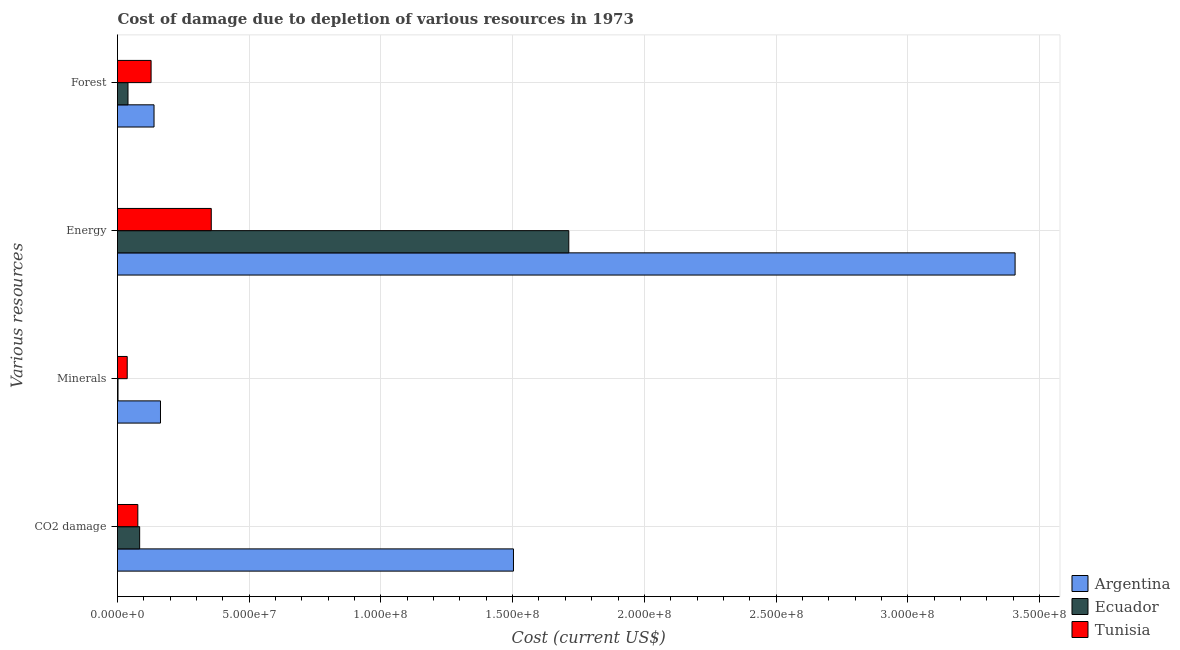How many different coloured bars are there?
Your response must be concise. 3. How many groups of bars are there?
Provide a short and direct response. 4. Are the number of bars per tick equal to the number of legend labels?
Your response must be concise. Yes. Are the number of bars on each tick of the Y-axis equal?
Make the answer very short. Yes. How many bars are there on the 3rd tick from the top?
Make the answer very short. 3. How many bars are there on the 3rd tick from the bottom?
Provide a succinct answer. 3. What is the label of the 4th group of bars from the top?
Your response must be concise. CO2 damage. What is the cost of damage due to depletion of energy in Tunisia?
Provide a succinct answer. 3.56e+07. Across all countries, what is the maximum cost of damage due to depletion of forests?
Make the answer very short. 1.39e+07. Across all countries, what is the minimum cost of damage due to depletion of minerals?
Keep it short and to the point. 1.93e+05. In which country was the cost of damage due to depletion of coal minimum?
Keep it short and to the point. Tunisia. What is the total cost of damage due to depletion of coal in the graph?
Offer a very short reply. 1.66e+08. What is the difference between the cost of damage due to depletion of energy in Tunisia and that in Argentina?
Your answer should be very brief. -3.05e+08. What is the difference between the cost of damage due to depletion of coal in Tunisia and the cost of damage due to depletion of energy in Ecuador?
Provide a short and direct response. -1.64e+08. What is the average cost of damage due to depletion of coal per country?
Give a very brief answer. 5.55e+07. What is the difference between the cost of damage due to depletion of coal and cost of damage due to depletion of energy in Argentina?
Keep it short and to the point. -1.90e+08. In how many countries, is the cost of damage due to depletion of coal greater than 130000000 US$?
Offer a very short reply. 1. What is the ratio of the cost of damage due to depletion of minerals in Ecuador to that in Argentina?
Give a very brief answer. 0.01. What is the difference between the highest and the second highest cost of damage due to depletion of minerals?
Make the answer very short. 1.26e+07. What is the difference between the highest and the lowest cost of damage due to depletion of coal?
Give a very brief answer. 1.43e+08. Is the sum of the cost of damage due to depletion of forests in Argentina and Tunisia greater than the maximum cost of damage due to depletion of coal across all countries?
Your response must be concise. No. What does the 3rd bar from the bottom in Forest represents?
Your answer should be compact. Tunisia. What is the difference between two consecutive major ticks on the X-axis?
Offer a very short reply. 5.00e+07. Are the values on the major ticks of X-axis written in scientific E-notation?
Your response must be concise. Yes. Does the graph contain any zero values?
Your answer should be very brief. No. Where does the legend appear in the graph?
Keep it short and to the point. Bottom right. What is the title of the graph?
Make the answer very short. Cost of damage due to depletion of various resources in 1973 . What is the label or title of the X-axis?
Ensure brevity in your answer.  Cost (current US$). What is the label or title of the Y-axis?
Give a very brief answer. Various resources. What is the Cost (current US$) in Argentina in CO2 damage?
Make the answer very short. 1.50e+08. What is the Cost (current US$) of Ecuador in CO2 damage?
Keep it short and to the point. 8.41e+06. What is the Cost (current US$) in Tunisia in CO2 damage?
Offer a terse response. 7.72e+06. What is the Cost (current US$) of Argentina in Minerals?
Make the answer very short. 1.63e+07. What is the Cost (current US$) of Ecuador in Minerals?
Keep it short and to the point. 1.93e+05. What is the Cost (current US$) of Tunisia in Minerals?
Your answer should be very brief. 3.69e+06. What is the Cost (current US$) of Argentina in Energy?
Keep it short and to the point. 3.41e+08. What is the Cost (current US$) in Ecuador in Energy?
Ensure brevity in your answer.  1.71e+08. What is the Cost (current US$) in Tunisia in Energy?
Give a very brief answer. 3.56e+07. What is the Cost (current US$) in Argentina in Forest?
Provide a succinct answer. 1.39e+07. What is the Cost (current US$) of Ecuador in Forest?
Your response must be concise. 3.98e+06. What is the Cost (current US$) of Tunisia in Forest?
Your response must be concise. 1.28e+07. Across all Various resources, what is the maximum Cost (current US$) of Argentina?
Your answer should be very brief. 3.41e+08. Across all Various resources, what is the maximum Cost (current US$) in Ecuador?
Keep it short and to the point. 1.71e+08. Across all Various resources, what is the maximum Cost (current US$) of Tunisia?
Offer a very short reply. 3.56e+07. Across all Various resources, what is the minimum Cost (current US$) of Argentina?
Offer a very short reply. 1.39e+07. Across all Various resources, what is the minimum Cost (current US$) of Ecuador?
Make the answer very short. 1.93e+05. Across all Various resources, what is the minimum Cost (current US$) in Tunisia?
Your answer should be compact. 3.69e+06. What is the total Cost (current US$) of Argentina in the graph?
Give a very brief answer. 5.21e+08. What is the total Cost (current US$) of Ecuador in the graph?
Give a very brief answer. 1.84e+08. What is the total Cost (current US$) of Tunisia in the graph?
Offer a terse response. 5.97e+07. What is the difference between the Cost (current US$) of Argentina in CO2 damage and that in Minerals?
Give a very brief answer. 1.34e+08. What is the difference between the Cost (current US$) in Ecuador in CO2 damage and that in Minerals?
Make the answer very short. 8.22e+06. What is the difference between the Cost (current US$) of Tunisia in CO2 damage and that in Minerals?
Ensure brevity in your answer.  4.03e+06. What is the difference between the Cost (current US$) of Argentina in CO2 damage and that in Energy?
Your answer should be very brief. -1.90e+08. What is the difference between the Cost (current US$) of Ecuador in CO2 damage and that in Energy?
Your response must be concise. -1.63e+08. What is the difference between the Cost (current US$) of Tunisia in CO2 damage and that in Energy?
Your answer should be compact. -2.79e+07. What is the difference between the Cost (current US$) in Argentina in CO2 damage and that in Forest?
Offer a very short reply. 1.36e+08. What is the difference between the Cost (current US$) of Ecuador in CO2 damage and that in Forest?
Provide a succinct answer. 4.42e+06. What is the difference between the Cost (current US$) of Tunisia in CO2 damage and that in Forest?
Provide a succinct answer. -5.03e+06. What is the difference between the Cost (current US$) of Argentina in Minerals and that in Energy?
Provide a short and direct response. -3.24e+08. What is the difference between the Cost (current US$) in Ecuador in Minerals and that in Energy?
Ensure brevity in your answer.  -1.71e+08. What is the difference between the Cost (current US$) in Tunisia in Minerals and that in Energy?
Offer a very short reply. -3.19e+07. What is the difference between the Cost (current US$) of Argentina in Minerals and that in Forest?
Your answer should be very brief. 2.45e+06. What is the difference between the Cost (current US$) in Ecuador in Minerals and that in Forest?
Offer a terse response. -3.79e+06. What is the difference between the Cost (current US$) of Tunisia in Minerals and that in Forest?
Keep it short and to the point. -9.06e+06. What is the difference between the Cost (current US$) of Argentina in Energy and that in Forest?
Your response must be concise. 3.27e+08. What is the difference between the Cost (current US$) of Ecuador in Energy and that in Forest?
Provide a succinct answer. 1.67e+08. What is the difference between the Cost (current US$) of Tunisia in Energy and that in Forest?
Your response must be concise. 2.28e+07. What is the difference between the Cost (current US$) in Argentina in CO2 damage and the Cost (current US$) in Ecuador in Minerals?
Provide a short and direct response. 1.50e+08. What is the difference between the Cost (current US$) of Argentina in CO2 damage and the Cost (current US$) of Tunisia in Minerals?
Ensure brevity in your answer.  1.47e+08. What is the difference between the Cost (current US$) of Ecuador in CO2 damage and the Cost (current US$) of Tunisia in Minerals?
Keep it short and to the point. 4.72e+06. What is the difference between the Cost (current US$) in Argentina in CO2 damage and the Cost (current US$) in Ecuador in Energy?
Make the answer very short. -2.10e+07. What is the difference between the Cost (current US$) in Argentina in CO2 damage and the Cost (current US$) in Tunisia in Energy?
Offer a very short reply. 1.15e+08. What is the difference between the Cost (current US$) in Ecuador in CO2 damage and the Cost (current US$) in Tunisia in Energy?
Your answer should be very brief. -2.72e+07. What is the difference between the Cost (current US$) in Argentina in CO2 damage and the Cost (current US$) in Ecuador in Forest?
Your answer should be compact. 1.46e+08. What is the difference between the Cost (current US$) of Argentina in CO2 damage and the Cost (current US$) of Tunisia in Forest?
Offer a very short reply. 1.38e+08. What is the difference between the Cost (current US$) in Ecuador in CO2 damage and the Cost (current US$) in Tunisia in Forest?
Offer a terse response. -4.34e+06. What is the difference between the Cost (current US$) of Argentina in Minerals and the Cost (current US$) of Ecuador in Energy?
Keep it short and to the point. -1.55e+08. What is the difference between the Cost (current US$) in Argentina in Minerals and the Cost (current US$) in Tunisia in Energy?
Your response must be concise. -1.93e+07. What is the difference between the Cost (current US$) in Ecuador in Minerals and the Cost (current US$) in Tunisia in Energy?
Offer a very short reply. -3.54e+07. What is the difference between the Cost (current US$) of Argentina in Minerals and the Cost (current US$) of Ecuador in Forest?
Make the answer very short. 1.23e+07. What is the difference between the Cost (current US$) in Argentina in Minerals and the Cost (current US$) in Tunisia in Forest?
Ensure brevity in your answer.  3.56e+06. What is the difference between the Cost (current US$) in Ecuador in Minerals and the Cost (current US$) in Tunisia in Forest?
Ensure brevity in your answer.  -1.26e+07. What is the difference between the Cost (current US$) in Argentina in Energy and the Cost (current US$) in Ecuador in Forest?
Make the answer very short. 3.37e+08. What is the difference between the Cost (current US$) in Argentina in Energy and the Cost (current US$) in Tunisia in Forest?
Offer a very short reply. 3.28e+08. What is the difference between the Cost (current US$) in Ecuador in Energy and the Cost (current US$) in Tunisia in Forest?
Offer a very short reply. 1.59e+08. What is the average Cost (current US$) of Argentina per Various resources?
Provide a short and direct response. 1.30e+08. What is the average Cost (current US$) of Ecuador per Various resources?
Your answer should be very brief. 4.60e+07. What is the average Cost (current US$) of Tunisia per Various resources?
Keep it short and to the point. 1.49e+07. What is the difference between the Cost (current US$) in Argentina and Cost (current US$) in Ecuador in CO2 damage?
Your answer should be compact. 1.42e+08. What is the difference between the Cost (current US$) of Argentina and Cost (current US$) of Tunisia in CO2 damage?
Keep it short and to the point. 1.43e+08. What is the difference between the Cost (current US$) of Ecuador and Cost (current US$) of Tunisia in CO2 damage?
Keep it short and to the point. 6.91e+05. What is the difference between the Cost (current US$) of Argentina and Cost (current US$) of Ecuador in Minerals?
Keep it short and to the point. 1.61e+07. What is the difference between the Cost (current US$) of Argentina and Cost (current US$) of Tunisia in Minerals?
Give a very brief answer. 1.26e+07. What is the difference between the Cost (current US$) in Ecuador and Cost (current US$) in Tunisia in Minerals?
Ensure brevity in your answer.  -3.50e+06. What is the difference between the Cost (current US$) of Argentina and Cost (current US$) of Ecuador in Energy?
Keep it short and to the point. 1.69e+08. What is the difference between the Cost (current US$) in Argentina and Cost (current US$) in Tunisia in Energy?
Ensure brevity in your answer.  3.05e+08. What is the difference between the Cost (current US$) of Ecuador and Cost (current US$) of Tunisia in Energy?
Provide a short and direct response. 1.36e+08. What is the difference between the Cost (current US$) in Argentina and Cost (current US$) in Ecuador in Forest?
Ensure brevity in your answer.  9.88e+06. What is the difference between the Cost (current US$) of Argentina and Cost (current US$) of Tunisia in Forest?
Give a very brief answer. 1.12e+06. What is the difference between the Cost (current US$) of Ecuador and Cost (current US$) of Tunisia in Forest?
Make the answer very short. -8.77e+06. What is the ratio of the Cost (current US$) of Argentina in CO2 damage to that in Minerals?
Ensure brevity in your answer.  9.21. What is the ratio of the Cost (current US$) of Ecuador in CO2 damage to that in Minerals?
Provide a succinct answer. 43.66. What is the ratio of the Cost (current US$) of Tunisia in CO2 damage to that in Minerals?
Provide a succinct answer. 2.09. What is the ratio of the Cost (current US$) of Argentina in CO2 damage to that in Energy?
Offer a terse response. 0.44. What is the ratio of the Cost (current US$) of Ecuador in CO2 damage to that in Energy?
Provide a succinct answer. 0.05. What is the ratio of the Cost (current US$) of Tunisia in CO2 damage to that in Energy?
Give a very brief answer. 0.22. What is the ratio of the Cost (current US$) of Argentina in CO2 damage to that in Forest?
Your response must be concise. 10.84. What is the ratio of the Cost (current US$) in Ecuador in CO2 damage to that in Forest?
Ensure brevity in your answer.  2.11. What is the ratio of the Cost (current US$) of Tunisia in CO2 damage to that in Forest?
Your response must be concise. 0.61. What is the ratio of the Cost (current US$) of Argentina in Minerals to that in Energy?
Your response must be concise. 0.05. What is the ratio of the Cost (current US$) in Ecuador in Minerals to that in Energy?
Provide a short and direct response. 0. What is the ratio of the Cost (current US$) of Tunisia in Minerals to that in Energy?
Your answer should be compact. 0.1. What is the ratio of the Cost (current US$) in Argentina in Minerals to that in Forest?
Make the answer very short. 1.18. What is the ratio of the Cost (current US$) in Ecuador in Minerals to that in Forest?
Your answer should be very brief. 0.05. What is the ratio of the Cost (current US$) in Tunisia in Minerals to that in Forest?
Provide a short and direct response. 0.29. What is the ratio of the Cost (current US$) of Argentina in Energy to that in Forest?
Make the answer very short. 24.57. What is the ratio of the Cost (current US$) in Ecuador in Energy to that in Forest?
Make the answer very short. 42.99. What is the ratio of the Cost (current US$) of Tunisia in Energy to that in Forest?
Offer a very short reply. 2.79. What is the difference between the highest and the second highest Cost (current US$) of Argentina?
Make the answer very short. 1.90e+08. What is the difference between the highest and the second highest Cost (current US$) of Ecuador?
Give a very brief answer. 1.63e+08. What is the difference between the highest and the second highest Cost (current US$) in Tunisia?
Your response must be concise. 2.28e+07. What is the difference between the highest and the lowest Cost (current US$) of Argentina?
Ensure brevity in your answer.  3.27e+08. What is the difference between the highest and the lowest Cost (current US$) in Ecuador?
Give a very brief answer. 1.71e+08. What is the difference between the highest and the lowest Cost (current US$) in Tunisia?
Ensure brevity in your answer.  3.19e+07. 